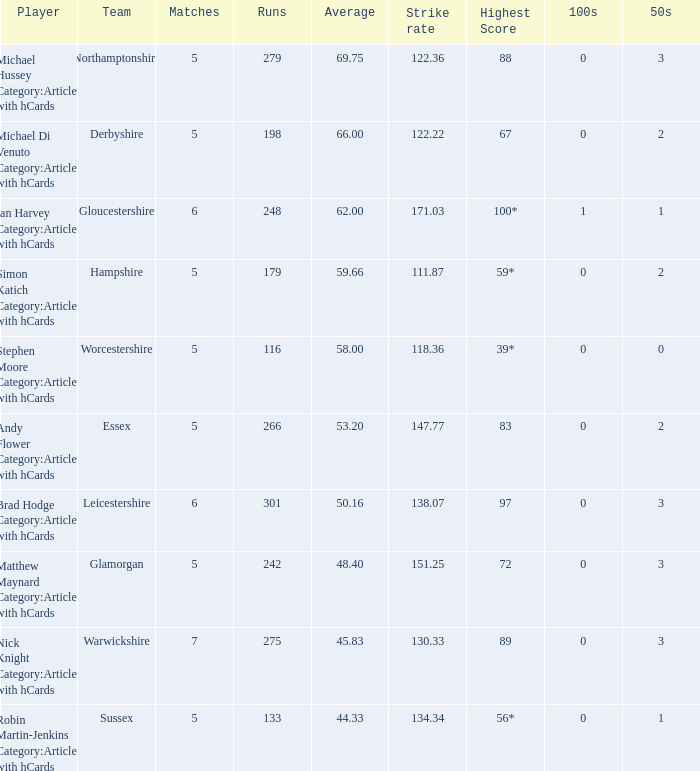Could you help me parse every detail presented in this table? {'header': ['Player', 'Team', 'Matches', 'Runs', 'Average', 'Strike rate', 'Highest Score', '100s', '50s'], 'rows': [['Michael Hussey Category:Articles with hCards', 'Northamptonshire', '5', '279', '69.75', '122.36', '88', '0', '3'], ['Michael Di Venuto Category:Articles with hCards', 'Derbyshire', '5', '198', '66.00', '122.22', '67', '0', '2'], ['Ian Harvey Category:Articles with hCards', 'Gloucestershire', '6', '248', '62.00', '171.03', '100*', '1', '1'], ['Simon Katich Category:Articles with hCards', 'Hampshire', '5', '179', '59.66', '111.87', '59*', '0', '2'], ['Stephen Moore Category:Articles with hCards', 'Worcestershire', '5', '116', '58.00', '118.36', '39*', '0', '0'], ['Andy Flower Category:Articles with hCards', 'Essex', '5', '266', '53.20', '147.77', '83', '0', '2'], ['Brad Hodge Category:Articles with hCards', 'Leicestershire', '6', '301', '50.16', '138.07', '97', '0', '3'], ['Matthew Maynard Category:Articles with hCards', 'Glamorgan', '5', '242', '48.40', '151.25', '72', '0', '3'], ['Nick Knight Category:Articles with hCards', 'Warwickshire', '7', '275', '45.83', '130.33', '89', '0', '3'], ['Robin Martin-Jenkins Category:Articles with hCards', 'Sussex', '5', '133', '44.33', '134.34', '56*', '0', '1']]} What is sussex team's maximum score? 56*. 